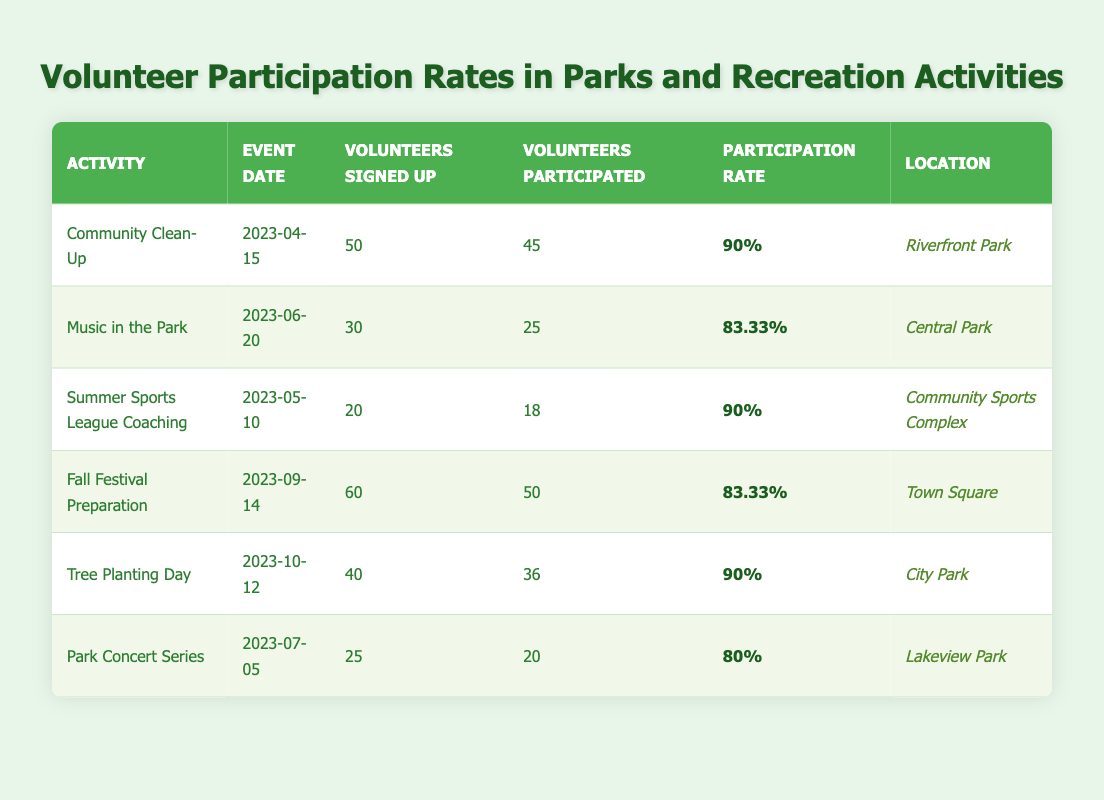What is the participation rate for the "Community Clean-Up" activity? The participation rate for the "Community Clean-Up" activity is listed in the corresponding row under the Participation Rate column. It shows 90%.
Answer: 90% How many volunteers participated in the "Music in the Park" activity? The number of volunteers who participated in the "Music in the Park" activity is found in the Volunteers Participated column for that activity. It shows 25 participants.
Answer: 25 Which activity had the highest number of volunteers signed up? By comparing the Volunteers Signed Up column for all activities, we can see that the "Fall Festival Preparation" activity had the highest number with 60 volunteers signed up.
Answer: Fall Festival Preparation What was the average participation rate for all events listed? To find the average participation rate, sum up the participation rates of all events: (90 + 83.33 + 90 + 83.33 + 90 + 80) = 516.66. Then, divide this total by the number of events, which is 6: 516.66 / 6 = 86.11.
Answer: 86.11 Did the "Tree Planting Day" have a higher participation rate than the "Park Concert Series"? The participation rate for "Tree Planting Day" is 90%, while for "Park Concert Series" it is 80%. Since 90 is greater than 80, "Tree Planting Day" had a higher participation rate.
Answer: Yes Which location had the second-highest participation rate and what was it? We must first identify the participation rates for each event and sort them. The second highest participation rates are 83.33%, which is shared by "Music in the Park" and "Fall Festival Preparation." Both activities had the same participation rate, but "Fall Festival Preparation" is higher in terms of volunteers participated. Thus, the second-highest location is Town Square with 83.33%.
Answer: Town Square, 83.33% Is the number of volunteers who participated in "Summer Sports League Coaching" greater than the volunteers who participated in "Music in the Park"? The volunteers participated in "Summer Sports League Coaching" is 18, while for "Music in the Park" it is 25. Since 18 is less than 25, the answer is no.
Answer: No What is the total number of volunteers signed up for all events? To find the total number of volunteers signed up, we need to sum the Volunteers Signed Up: 50 + 30 + 20 + 60 + 40 + 25 = 225.
Answer: 225 Which event had the lowest participation rate and what was that rate? By inspecting the Participation Rate column, we see that "Park Concert Series" had the lowest participation rate with 80%.
Answer: Park Concert Series, 80% 